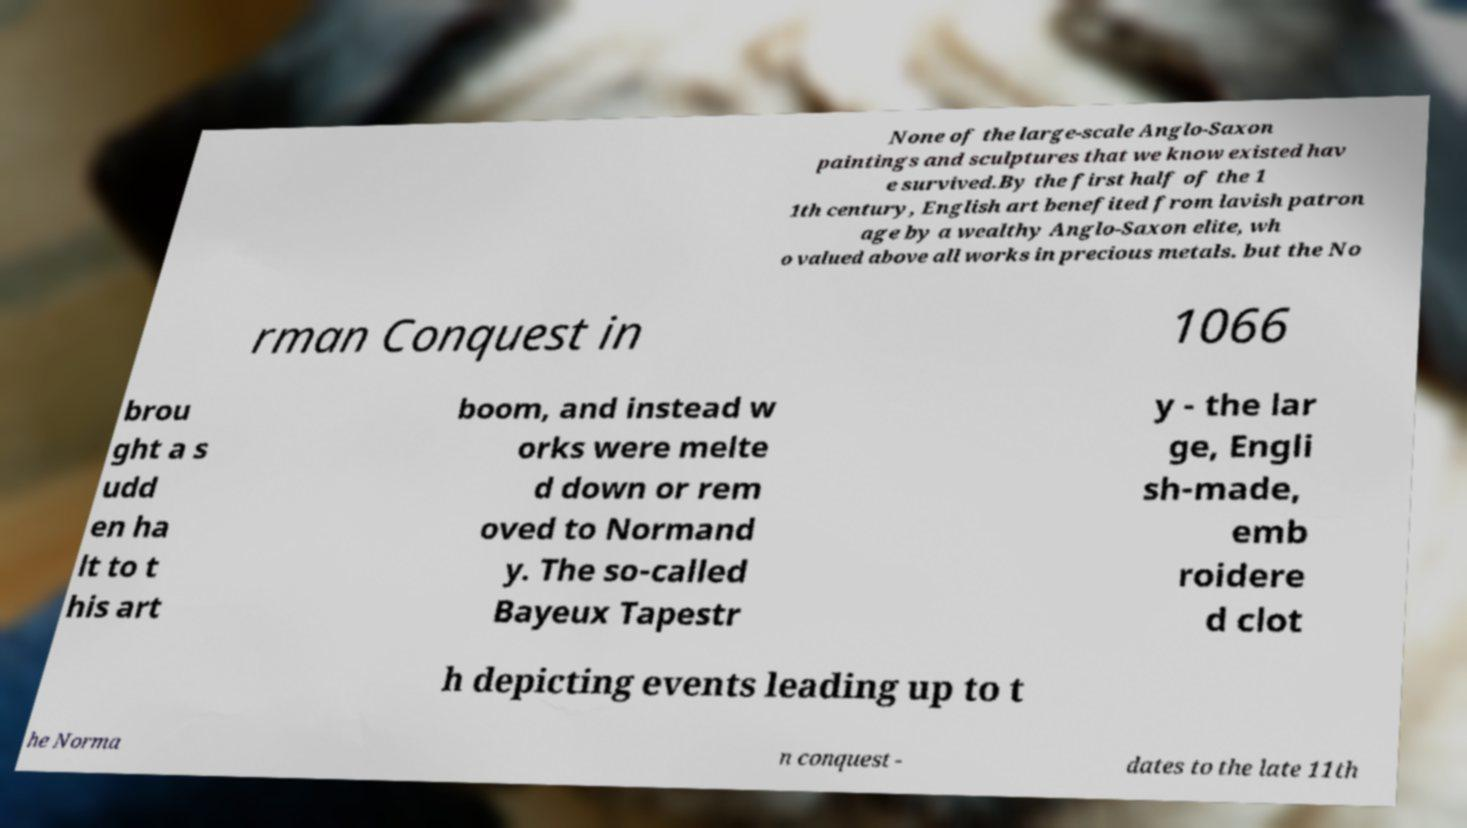What messages or text are displayed in this image? I need them in a readable, typed format. None of the large-scale Anglo-Saxon paintings and sculptures that we know existed hav e survived.By the first half of the 1 1th century, English art benefited from lavish patron age by a wealthy Anglo-Saxon elite, wh o valued above all works in precious metals. but the No rman Conquest in 1066 brou ght a s udd en ha lt to t his art boom, and instead w orks were melte d down or rem oved to Normand y. The so-called Bayeux Tapestr y - the lar ge, Engli sh-made, emb roidere d clot h depicting events leading up to t he Norma n conquest - dates to the late 11th 